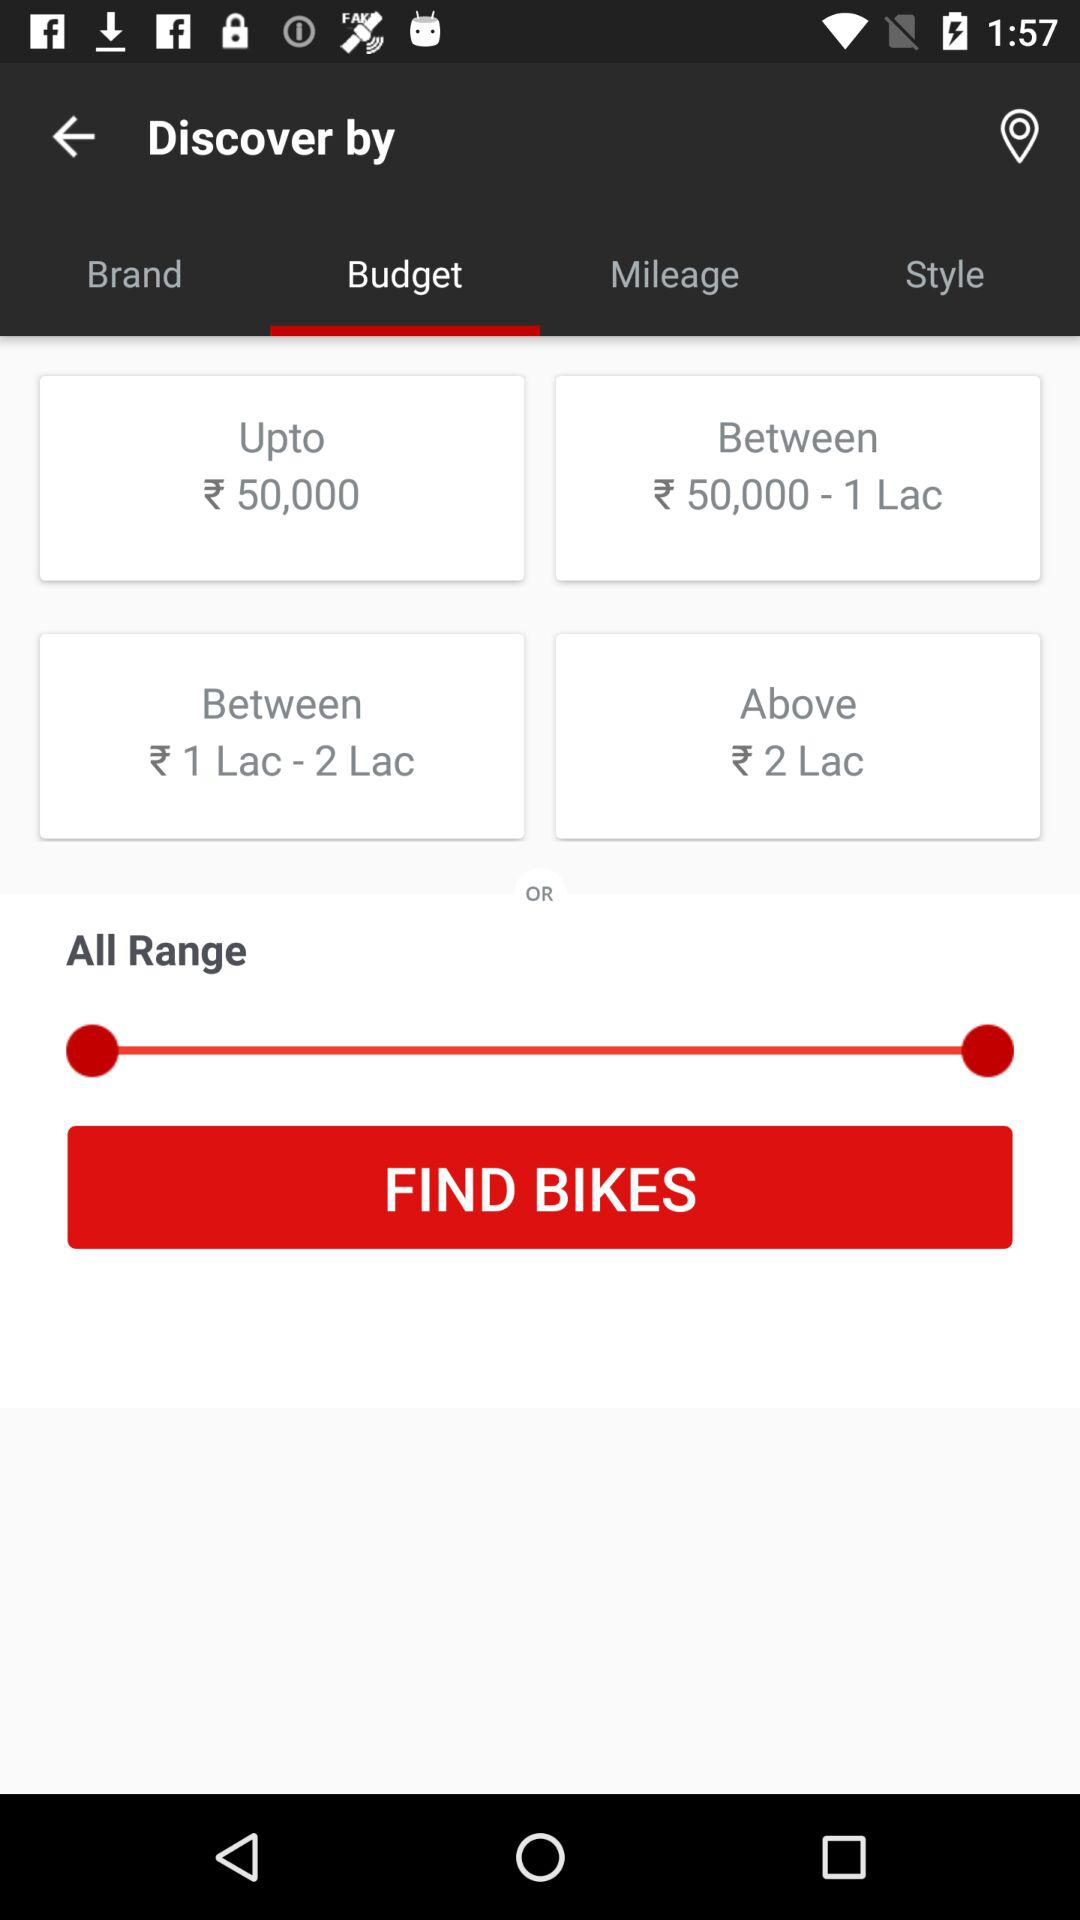How many price ranges are there?
Answer the question using a single word or phrase. 4 